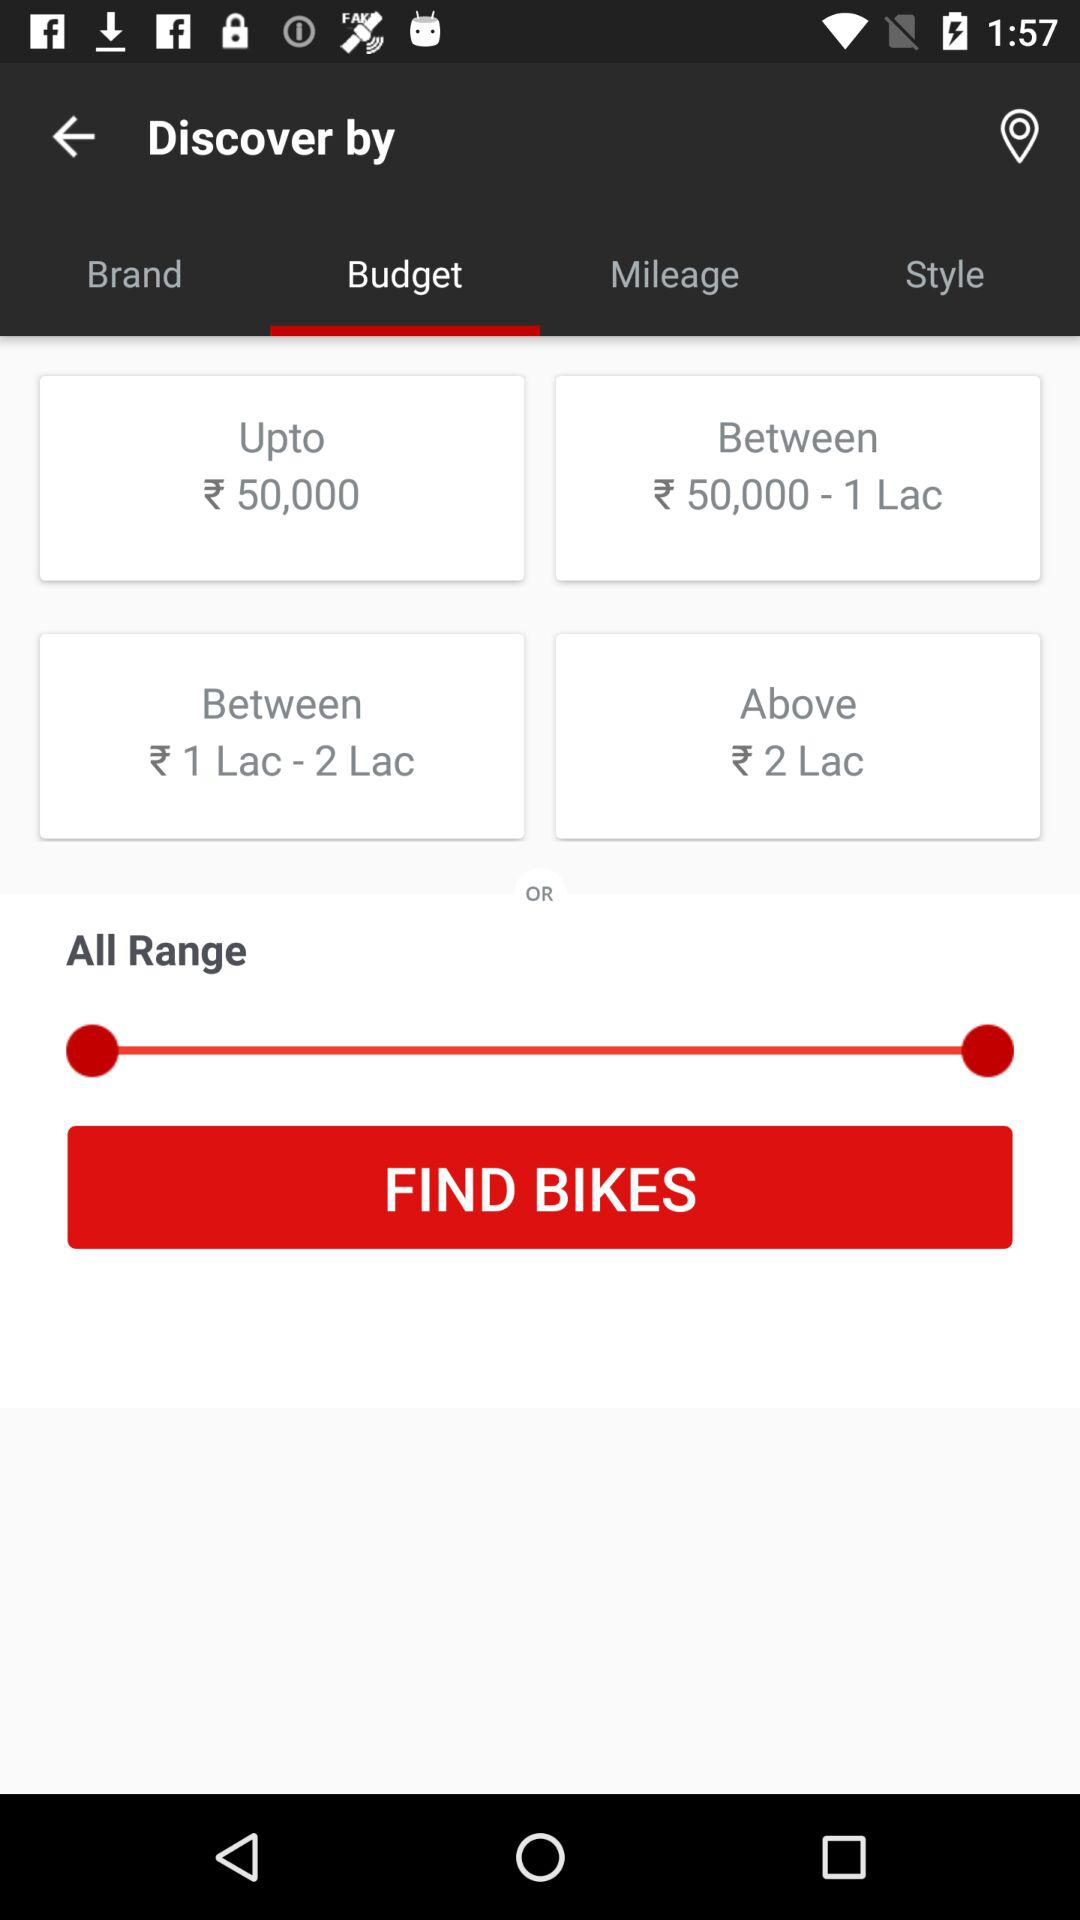How many price ranges are there?
Answer the question using a single word or phrase. 4 